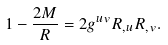<formula> <loc_0><loc_0><loc_500><loc_500>1 - \frac { 2 M } { R } = 2 g ^ { u v } R _ { , u } R _ { , v } .</formula> 